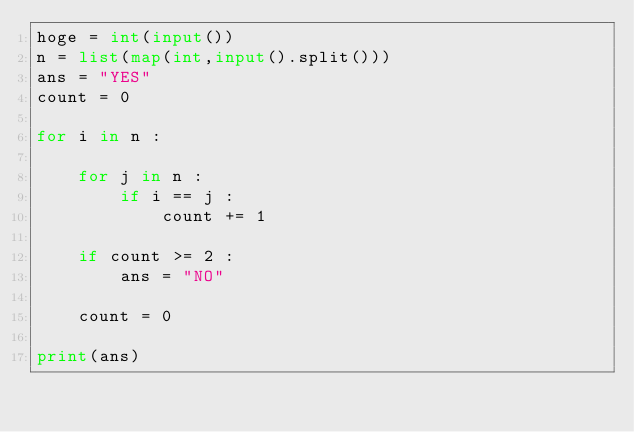Convert code to text. <code><loc_0><loc_0><loc_500><loc_500><_Python_>hoge = int(input())
n = list(map(int,input().split()))
ans = "YES"
count = 0

for i in n :
    
    for j in n :
        if i == j :
            count += 1
    
    if count >= 2 :
        ans = "NO"
    
    count = 0

print(ans)</code> 